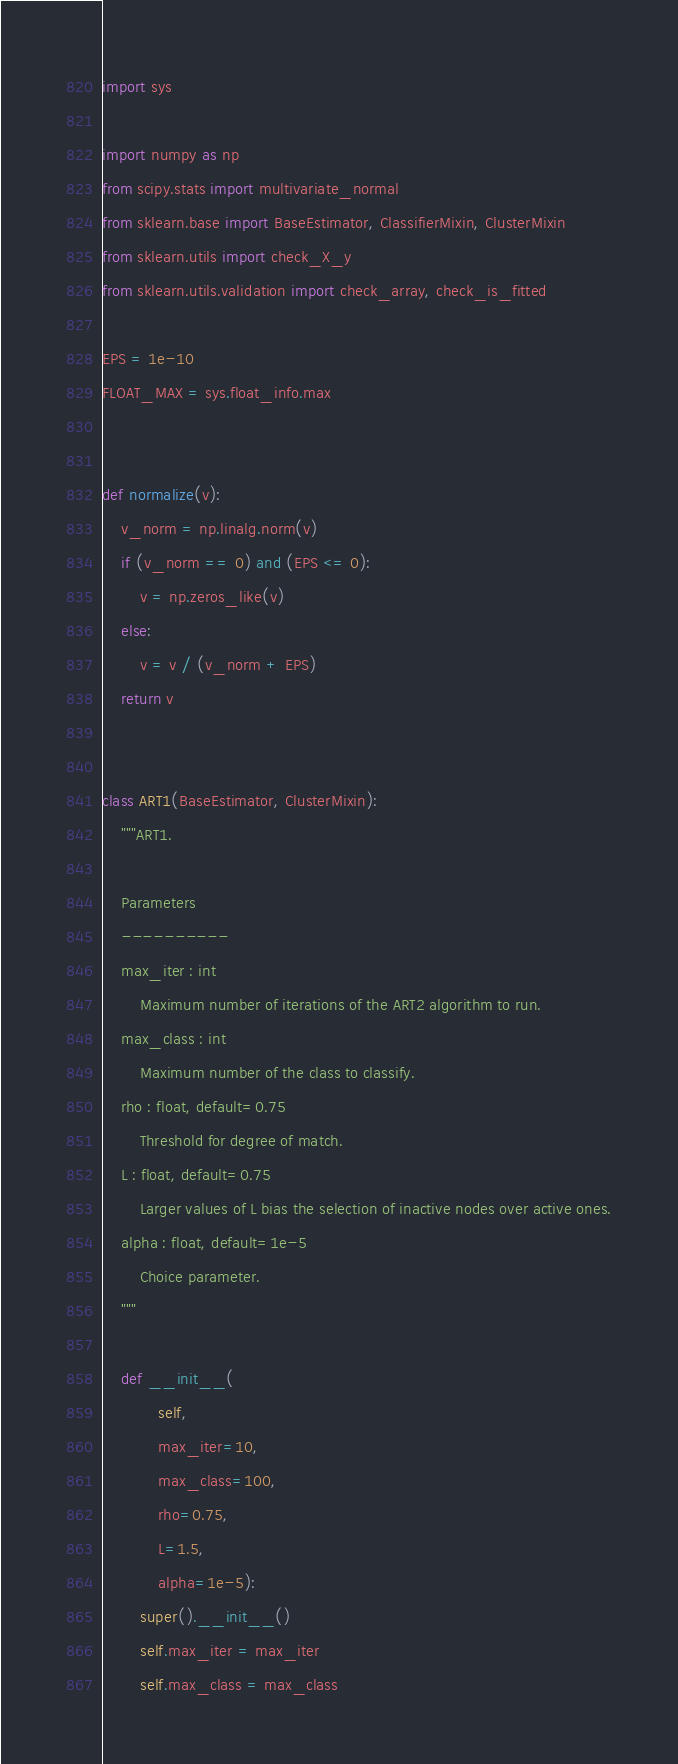<code> <loc_0><loc_0><loc_500><loc_500><_Python_>import sys

import numpy as np
from scipy.stats import multivariate_normal
from sklearn.base import BaseEstimator, ClassifierMixin, ClusterMixin
from sklearn.utils import check_X_y
from sklearn.utils.validation import check_array, check_is_fitted

EPS = 1e-10
FLOAT_MAX = sys.float_info.max


def normalize(v):
    v_norm = np.linalg.norm(v)
    if (v_norm == 0) and (EPS <= 0):
        v = np.zeros_like(v)
    else:
        v = v / (v_norm + EPS)
    return v


class ART1(BaseEstimator, ClusterMixin):
    """ART1.

    Parameters
    ----------
    max_iter : int
        Maximum number of iterations of the ART2 algorithm to run.
    max_class : int
        Maximum number of the class to classify.
    rho : float, default=0.75
        Threshold for degree of match.
    L : float, default=0.75
        Larger values of L bias the selection of inactive nodes over active ones.
    alpha : float, default=1e-5
        Choice parameter.
    """

    def __init__(
            self,
            max_iter=10,
            max_class=100,
            rho=0.75,
            L=1.5,
            alpha=1e-5):
        super().__init__()
        self.max_iter = max_iter
        self.max_class = max_class</code> 